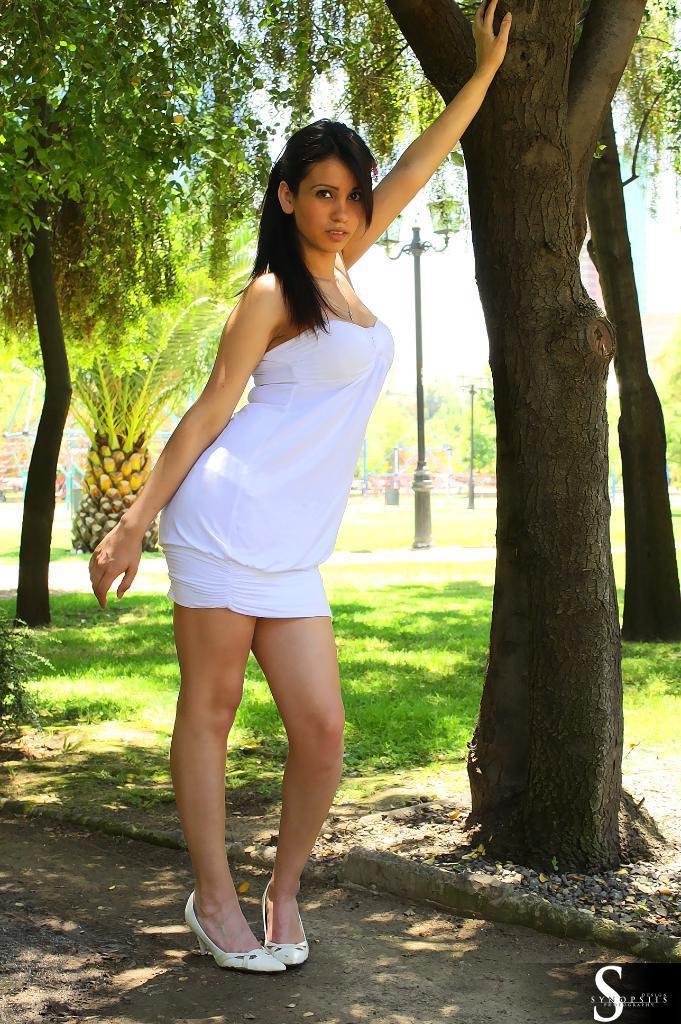Could you give a brief overview of what you see in this image? In this image I can see the person standing and the person is wearing white color dress. In the background I can see few trees in green color, few light poles and the sky is in white color. 